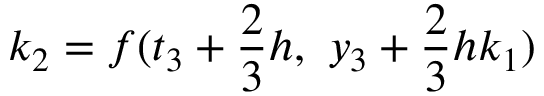<formula> <loc_0><loc_0><loc_500><loc_500>k _ { 2 } = f ( t _ { 3 } + { \frac { 2 } { 3 } } h , \ y _ { 3 } + { \frac { 2 } { 3 } } h k _ { 1 } )</formula> 